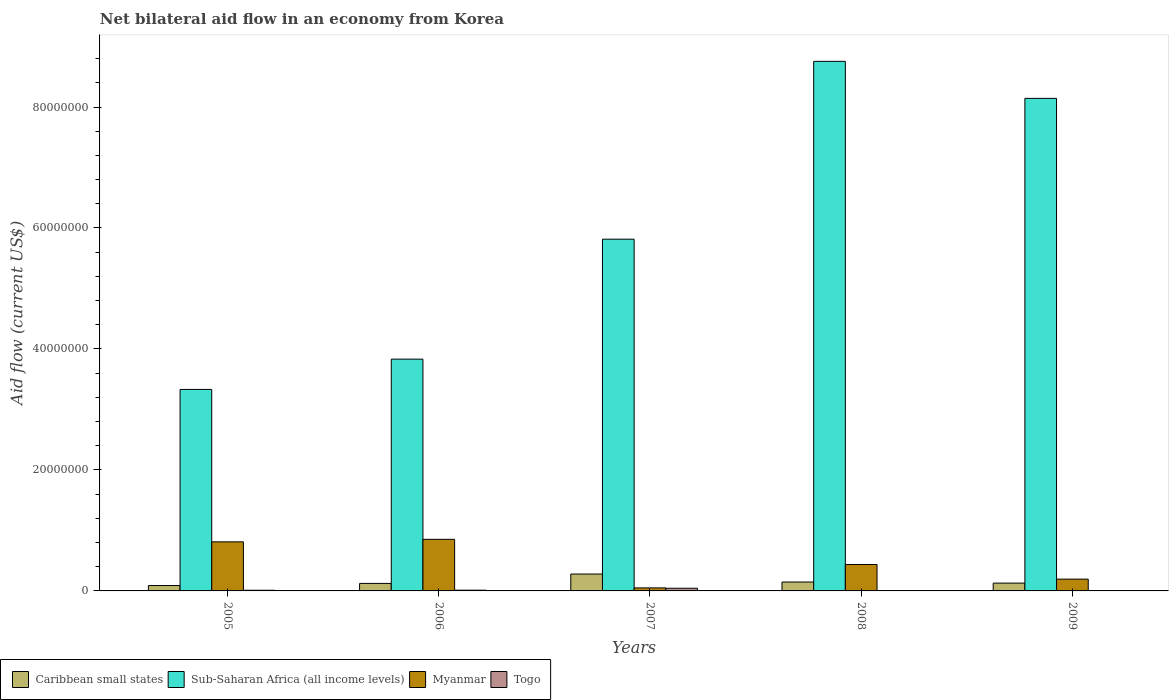How many different coloured bars are there?
Provide a short and direct response. 4. How many groups of bars are there?
Provide a succinct answer. 5. Are the number of bars on each tick of the X-axis equal?
Provide a succinct answer. Yes. How many bars are there on the 4th tick from the left?
Ensure brevity in your answer.  4. In how many cases, is the number of bars for a given year not equal to the number of legend labels?
Keep it short and to the point. 0. Across all years, what is the maximum net bilateral aid flow in Caribbean small states?
Ensure brevity in your answer.  2.79e+06. Across all years, what is the minimum net bilateral aid flow in Sub-Saharan Africa (all income levels)?
Offer a very short reply. 3.33e+07. In which year was the net bilateral aid flow in Myanmar minimum?
Offer a terse response. 2007. What is the total net bilateral aid flow in Caribbean small states in the graph?
Offer a very short reply. 7.68e+06. What is the difference between the net bilateral aid flow in Togo in 2006 and that in 2007?
Make the answer very short. -3.20e+05. What is the difference between the net bilateral aid flow in Togo in 2005 and the net bilateral aid flow in Sub-Saharan Africa (all income levels) in 2006?
Your response must be concise. -3.82e+07. What is the average net bilateral aid flow in Myanmar per year?
Ensure brevity in your answer.  4.69e+06. In the year 2009, what is the difference between the net bilateral aid flow in Caribbean small states and net bilateral aid flow in Togo?
Offer a very short reply. 1.23e+06. What is the ratio of the net bilateral aid flow in Togo in 2005 to that in 2008?
Provide a succinct answer. 1.83. Is the net bilateral aid flow in Myanmar in 2006 less than that in 2009?
Provide a succinct answer. No. What is the difference between the highest and the second highest net bilateral aid flow in Togo?
Provide a succinct answer. 3.20e+05. What is the difference between the highest and the lowest net bilateral aid flow in Sub-Saharan Africa (all income levels)?
Offer a very short reply. 5.42e+07. Is it the case that in every year, the sum of the net bilateral aid flow in Myanmar and net bilateral aid flow in Togo is greater than the sum of net bilateral aid flow in Caribbean small states and net bilateral aid flow in Sub-Saharan Africa (all income levels)?
Make the answer very short. Yes. What does the 1st bar from the left in 2008 represents?
Your answer should be very brief. Caribbean small states. What does the 4th bar from the right in 2009 represents?
Offer a terse response. Caribbean small states. Is it the case that in every year, the sum of the net bilateral aid flow in Myanmar and net bilateral aid flow in Sub-Saharan Africa (all income levels) is greater than the net bilateral aid flow in Togo?
Provide a succinct answer. Yes. How many bars are there?
Provide a short and direct response. 20. How many years are there in the graph?
Keep it short and to the point. 5. Are the values on the major ticks of Y-axis written in scientific E-notation?
Your answer should be very brief. No. Does the graph contain any zero values?
Your answer should be compact. No. Does the graph contain grids?
Provide a short and direct response. No. Where does the legend appear in the graph?
Your answer should be compact. Bottom left. How many legend labels are there?
Keep it short and to the point. 4. How are the legend labels stacked?
Ensure brevity in your answer.  Horizontal. What is the title of the graph?
Provide a succinct answer. Net bilateral aid flow in an economy from Korea. Does "Russian Federation" appear as one of the legend labels in the graph?
Ensure brevity in your answer.  No. What is the label or title of the X-axis?
Make the answer very short. Years. What is the Aid flow (current US$) in Caribbean small states in 2005?
Ensure brevity in your answer.  8.90e+05. What is the Aid flow (current US$) of Sub-Saharan Africa (all income levels) in 2005?
Ensure brevity in your answer.  3.33e+07. What is the Aid flow (current US$) in Myanmar in 2005?
Offer a terse response. 8.11e+06. What is the Aid flow (current US$) of Caribbean small states in 2006?
Give a very brief answer. 1.24e+06. What is the Aid flow (current US$) of Sub-Saharan Africa (all income levels) in 2006?
Your response must be concise. 3.83e+07. What is the Aid flow (current US$) in Myanmar in 2006?
Your response must be concise. 8.53e+06. What is the Aid flow (current US$) of Togo in 2006?
Make the answer very short. 1.20e+05. What is the Aid flow (current US$) in Caribbean small states in 2007?
Your answer should be very brief. 2.79e+06. What is the Aid flow (current US$) of Sub-Saharan Africa (all income levels) in 2007?
Your answer should be very brief. 5.82e+07. What is the Aid flow (current US$) of Myanmar in 2007?
Provide a short and direct response. 5.00e+05. What is the Aid flow (current US$) of Togo in 2007?
Your answer should be very brief. 4.40e+05. What is the Aid flow (current US$) in Caribbean small states in 2008?
Make the answer very short. 1.47e+06. What is the Aid flow (current US$) of Sub-Saharan Africa (all income levels) in 2008?
Ensure brevity in your answer.  8.76e+07. What is the Aid flow (current US$) in Myanmar in 2008?
Give a very brief answer. 4.37e+06. What is the Aid flow (current US$) of Togo in 2008?
Your answer should be very brief. 6.00e+04. What is the Aid flow (current US$) in Caribbean small states in 2009?
Provide a short and direct response. 1.29e+06. What is the Aid flow (current US$) in Sub-Saharan Africa (all income levels) in 2009?
Your response must be concise. 8.14e+07. What is the Aid flow (current US$) of Myanmar in 2009?
Make the answer very short. 1.95e+06. Across all years, what is the maximum Aid flow (current US$) of Caribbean small states?
Make the answer very short. 2.79e+06. Across all years, what is the maximum Aid flow (current US$) of Sub-Saharan Africa (all income levels)?
Keep it short and to the point. 8.76e+07. Across all years, what is the maximum Aid flow (current US$) of Myanmar?
Your response must be concise. 8.53e+06. Across all years, what is the minimum Aid flow (current US$) in Caribbean small states?
Offer a very short reply. 8.90e+05. Across all years, what is the minimum Aid flow (current US$) in Sub-Saharan Africa (all income levels)?
Give a very brief answer. 3.33e+07. What is the total Aid flow (current US$) in Caribbean small states in the graph?
Keep it short and to the point. 7.68e+06. What is the total Aid flow (current US$) of Sub-Saharan Africa (all income levels) in the graph?
Offer a terse response. 2.99e+08. What is the total Aid flow (current US$) in Myanmar in the graph?
Offer a terse response. 2.35e+07. What is the total Aid flow (current US$) in Togo in the graph?
Ensure brevity in your answer.  7.90e+05. What is the difference between the Aid flow (current US$) of Caribbean small states in 2005 and that in 2006?
Provide a succinct answer. -3.50e+05. What is the difference between the Aid flow (current US$) in Sub-Saharan Africa (all income levels) in 2005 and that in 2006?
Ensure brevity in your answer.  -5.01e+06. What is the difference between the Aid flow (current US$) of Myanmar in 2005 and that in 2006?
Ensure brevity in your answer.  -4.20e+05. What is the difference between the Aid flow (current US$) in Togo in 2005 and that in 2006?
Keep it short and to the point. -10000. What is the difference between the Aid flow (current US$) of Caribbean small states in 2005 and that in 2007?
Provide a short and direct response. -1.90e+06. What is the difference between the Aid flow (current US$) in Sub-Saharan Africa (all income levels) in 2005 and that in 2007?
Make the answer very short. -2.48e+07. What is the difference between the Aid flow (current US$) of Myanmar in 2005 and that in 2007?
Make the answer very short. 7.61e+06. What is the difference between the Aid flow (current US$) in Togo in 2005 and that in 2007?
Provide a short and direct response. -3.30e+05. What is the difference between the Aid flow (current US$) in Caribbean small states in 2005 and that in 2008?
Offer a very short reply. -5.80e+05. What is the difference between the Aid flow (current US$) of Sub-Saharan Africa (all income levels) in 2005 and that in 2008?
Your answer should be compact. -5.42e+07. What is the difference between the Aid flow (current US$) in Myanmar in 2005 and that in 2008?
Your answer should be compact. 3.74e+06. What is the difference between the Aid flow (current US$) in Caribbean small states in 2005 and that in 2009?
Keep it short and to the point. -4.00e+05. What is the difference between the Aid flow (current US$) in Sub-Saharan Africa (all income levels) in 2005 and that in 2009?
Ensure brevity in your answer.  -4.81e+07. What is the difference between the Aid flow (current US$) in Myanmar in 2005 and that in 2009?
Make the answer very short. 6.16e+06. What is the difference between the Aid flow (current US$) of Caribbean small states in 2006 and that in 2007?
Your response must be concise. -1.55e+06. What is the difference between the Aid flow (current US$) in Sub-Saharan Africa (all income levels) in 2006 and that in 2007?
Give a very brief answer. -1.98e+07. What is the difference between the Aid flow (current US$) in Myanmar in 2006 and that in 2007?
Your answer should be compact. 8.03e+06. What is the difference between the Aid flow (current US$) of Togo in 2006 and that in 2007?
Provide a succinct answer. -3.20e+05. What is the difference between the Aid flow (current US$) of Caribbean small states in 2006 and that in 2008?
Keep it short and to the point. -2.30e+05. What is the difference between the Aid flow (current US$) of Sub-Saharan Africa (all income levels) in 2006 and that in 2008?
Provide a short and direct response. -4.92e+07. What is the difference between the Aid flow (current US$) of Myanmar in 2006 and that in 2008?
Make the answer very short. 4.16e+06. What is the difference between the Aid flow (current US$) in Caribbean small states in 2006 and that in 2009?
Provide a succinct answer. -5.00e+04. What is the difference between the Aid flow (current US$) of Sub-Saharan Africa (all income levels) in 2006 and that in 2009?
Offer a terse response. -4.31e+07. What is the difference between the Aid flow (current US$) of Myanmar in 2006 and that in 2009?
Keep it short and to the point. 6.58e+06. What is the difference between the Aid flow (current US$) in Caribbean small states in 2007 and that in 2008?
Make the answer very short. 1.32e+06. What is the difference between the Aid flow (current US$) in Sub-Saharan Africa (all income levels) in 2007 and that in 2008?
Provide a short and direct response. -2.94e+07. What is the difference between the Aid flow (current US$) of Myanmar in 2007 and that in 2008?
Provide a short and direct response. -3.87e+06. What is the difference between the Aid flow (current US$) of Caribbean small states in 2007 and that in 2009?
Your answer should be compact. 1.50e+06. What is the difference between the Aid flow (current US$) of Sub-Saharan Africa (all income levels) in 2007 and that in 2009?
Your answer should be very brief. -2.33e+07. What is the difference between the Aid flow (current US$) in Myanmar in 2007 and that in 2009?
Your response must be concise. -1.45e+06. What is the difference between the Aid flow (current US$) in Togo in 2007 and that in 2009?
Offer a very short reply. 3.80e+05. What is the difference between the Aid flow (current US$) in Sub-Saharan Africa (all income levels) in 2008 and that in 2009?
Keep it short and to the point. 6.12e+06. What is the difference between the Aid flow (current US$) of Myanmar in 2008 and that in 2009?
Make the answer very short. 2.42e+06. What is the difference between the Aid flow (current US$) of Caribbean small states in 2005 and the Aid flow (current US$) of Sub-Saharan Africa (all income levels) in 2006?
Offer a terse response. -3.74e+07. What is the difference between the Aid flow (current US$) in Caribbean small states in 2005 and the Aid flow (current US$) in Myanmar in 2006?
Provide a short and direct response. -7.64e+06. What is the difference between the Aid flow (current US$) of Caribbean small states in 2005 and the Aid flow (current US$) of Togo in 2006?
Offer a terse response. 7.70e+05. What is the difference between the Aid flow (current US$) in Sub-Saharan Africa (all income levels) in 2005 and the Aid flow (current US$) in Myanmar in 2006?
Provide a short and direct response. 2.48e+07. What is the difference between the Aid flow (current US$) in Sub-Saharan Africa (all income levels) in 2005 and the Aid flow (current US$) in Togo in 2006?
Ensure brevity in your answer.  3.32e+07. What is the difference between the Aid flow (current US$) of Myanmar in 2005 and the Aid flow (current US$) of Togo in 2006?
Make the answer very short. 7.99e+06. What is the difference between the Aid flow (current US$) of Caribbean small states in 2005 and the Aid flow (current US$) of Sub-Saharan Africa (all income levels) in 2007?
Offer a very short reply. -5.73e+07. What is the difference between the Aid flow (current US$) of Caribbean small states in 2005 and the Aid flow (current US$) of Myanmar in 2007?
Give a very brief answer. 3.90e+05. What is the difference between the Aid flow (current US$) of Sub-Saharan Africa (all income levels) in 2005 and the Aid flow (current US$) of Myanmar in 2007?
Your response must be concise. 3.28e+07. What is the difference between the Aid flow (current US$) in Sub-Saharan Africa (all income levels) in 2005 and the Aid flow (current US$) in Togo in 2007?
Provide a succinct answer. 3.29e+07. What is the difference between the Aid flow (current US$) of Myanmar in 2005 and the Aid flow (current US$) of Togo in 2007?
Ensure brevity in your answer.  7.67e+06. What is the difference between the Aid flow (current US$) of Caribbean small states in 2005 and the Aid flow (current US$) of Sub-Saharan Africa (all income levels) in 2008?
Offer a very short reply. -8.67e+07. What is the difference between the Aid flow (current US$) of Caribbean small states in 2005 and the Aid flow (current US$) of Myanmar in 2008?
Give a very brief answer. -3.48e+06. What is the difference between the Aid flow (current US$) of Caribbean small states in 2005 and the Aid flow (current US$) of Togo in 2008?
Keep it short and to the point. 8.30e+05. What is the difference between the Aid flow (current US$) in Sub-Saharan Africa (all income levels) in 2005 and the Aid flow (current US$) in Myanmar in 2008?
Your answer should be very brief. 2.89e+07. What is the difference between the Aid flow (current US$) of Sub-Saharan Africa (all income levels) in 2005 and the Aid flow (current US$) of Togo in 2008?
Give a very brief answer. 3.32e+07. What is the difference between the Aid flow (current US$) in Myanmar in 2005 and the Aid flow (current US$) in Togo in 2008?
Provide a succinct answer. 8.05e+06. What is the difference between the Aid flow (current US$) in Caribbean small states in 2005 and the Aid flow (current US$) in Sub-Saharan Africa (all income levels) in 2009?
Give a very brief answer. -8.05e+07. What is the difference between the Aid flow (current US$) in Caribbean small states in 2005 and the Aid flow (current US$) in Myanmar in 2009?
Provide a short and direct response. -1.06e+06. What is the difference between the Aid flow (current US$) in Caribbean small states in 2005 and the Aid flow (current US$) in Togo in 2009?
Offer a very short reply. 8.30e+05. What is the difference between the Aid flow (current US$) of Sub-Saharan Africa (all income levels) in 2005 and the Aid flow (current US$) of Myanmar in 2009?
Your response must be concise. 3.14e+07. What is the difference between the Aid flow (current US$) in Sub-Saharan Africa (all income levels) in 2005 and the Aid flow (current US$) in Togo in 2009?
Your answer should be compact. 3.32e+07. What is the difference between the Aid flow (current US$) in Myanmar in 2005 and the Aid flow (current US$) in Togo in 2009?
Provide a short and direct response. 8.05e+06. What is the difference between the Aid flow (current US$) of Caribbean small states in 2006 and the Aid flow (current US$) of Sub-Saharan Africa (all income levels) in 2007?
Offer a terse response. -5.69e+07. What is the difference between the Aid flow (current US$) in Caribbean small states in 2006 and the Aid flow (current US$) in Myanmar in 2007?
Your answer should be compact. 7.40e+05. What is the difference between the Aid flow (current US$) in Caribbean small states in 2006 and the Aid flow (current US$) in Togo in 2007?
Make the answer very short. 8.00e+05. What is the difference between the Aid flow (current US$) in Sub-Saharan Africa (all income levels) in 2006 and the Aid flow (current US$) in Myanmar in 2007?
Give a very brief answer. 3.78e+07. What is the difference between the Aid flow (current US$) of Sub-Saharan Africa (all income levels) in 2006 and the Aid flow (current US$) of Togo in 2007?
Ensure brevity in your answer.  3.79e+07. What is the difference between the Aid flow (current US$) of Myanmar in 2006 and the Aid flow (current US$) of Togo in 2007?
Offer a very short reply. 8.09e+06. What is the difference between the Aid flow (current US$) in Caribbean small states in 2006 and the Aid flow (current US$) in Sub-Saharan Africa (all income levels) in 2008?
Offer a terse response. -8.63e+07. What is the difference between the Aid flow (current US$) of Caribbean small states in 2006 and the Aid flow (current US$) of Myanmar in 2008?
Give a very brief answer. -3.13e+06. What is the difference between the Aid flow (current US$) of Caribbean small states in 2006 and the Aid flow (current US$) of Togo in 2008?
Provide a succinct answer. 1.18e+06. What is the difference between the Aid flow (current US$) in Sub-Saharan Africa (all income levels) in 2006 and the Aid flow (current US$) in Myanmar in 2008?
Your response must be concise. 3.40e+07. What is the difference between the Aid flow (current US$) in Sub-Saharan Africa (all income levels) in 2006 and the Aid flow (current US$) in Togo in 2008?
Provide a succinct answer. 3.83e+07. What is the difference between the Aid flow (current US$) in Myanmar in 2006 and the Aid flow (current US$) in Togo in 2008?
Provide a short and direct response. 8.47e+06. What is the difference between the Aid flow (current US$) of Caribbean small states in 2006 and the Aid flow (current US$) of Sub-Saharan Africa (all income levels) in 2009?
Ensure brevity in your answer.  -8.02e+07. What is the difference between the Aid flow (current US$) of Caribbean small states in 2006 and the Aid flow (current US$) of Myanmar in 2009?
Provide a succinct answer. -7.10e+05. What is the difference between the Aid flow (current US$) of Caribbean small states in 2006 and the Aid flow (current US$) of Togo in 2009?
Your response must be concise. 1.18e+06. What is the difference between the Aid flow (current US$) of Sub-Saharan Africa (all income levels) in 2006 and the Aid flow (current US$) of Myanmar in 2009?
Give a very brief answer. 3.64e+07. What is the difference between the Aid flow (current US$) of Sub-Saharan Africa (all income levels) in 2006 and the Aid flow (current US$) of Togo in 2009?
Offer a terse response. 3.83e+07. What is the difference between the Aid flow (current US$) of Myanmar in 2006 and the Aid flow (current US$) of Togo in 2009?
Give a very brief answer. 8.47e+06. What is the difference between the Aid flow (current US$) of Caribbean small states in 2007 and the Aid flow (current US$) of Sub-Saharan Africa (all income levels) in 2008?
Your answer should be compact. -8.48e+07. What is the difference between the Aid flow (current US$) of Caribbean small states in 2007 and the Aid flow (current US$) of Myanmar in 2008?
Make the answer very short. -1.58e+06. What is the difference between the Aid flow (current US$) in Caribbean small states in 2007 and the Aid flow (current US$) in Togo in 2008?
Offer a terse response. 2.73e+06. What is the difference between the Aid flow (current US$) in Sub-Saharan Africa (all income levels) in 2007 and the Aid flow (current US$) in Myanmar in 2008?
Make the answer very short. 5.38e+07. What is the difference between the Aid flow (current US$) of Sub-Saharan Africa (all income levels) in 2007 and the Aid flow (current US$) of Togo in 2008?
Your answer should be very brief. 5.81e+07. What is the difference between the Aid flow (current US$) in Caribbean small states in 2007 and the Aid flow (current US$) in Sub-Saharan Africa (all income levels) in 2009?
Provide a short and direct response. -7.86e+07. What is the difference between the Aid flow (current US$) of Caribbean small states in 2007 and the Aid flow (current US$) of Myanmar in 2009?
Ensure brevity in your answer.  8.40e+05. What is the difference between the Aid flow (current US$) of Caribbean small states in 2007 and the Aid flow (current US$) of Togo in 2009?
Your answer should be compact. 2.73e+06. What is the difference between the Aid flow (current US$) in Sub-Saharan Africa (all income levels) in 2007 and the Aid flow (current US$) in Myanmar in 2009?
Your response must be concise. 5.62e+07. What is the difference between the Aid flow (current US$) of Sub-Saharan Africa (all income levels) in 2007 and the Aid flow (current US$) of Togo in 2009?
Provide a succinct answer. 5.81e+07. What is the difference between the Aid flow (current US$) in Caribbean small states in 2008 and the Aid flow (current US$) in Sub-Saharan Africa (all income levels) in 2009?
Provide a succinct answer. -8.00e+07. What is the difference between the Aid flow (current US$) of Caribbean small states in 2008 and the Aid flow (current US$) of Myanmar in 2009?
Provide a succinct answer. -4.80e+05. What is the difference between the Aid flow (current US$) in Caribbean small states in 2008 and the Aid flow (current US$) in Togo in 2009?
Keep it short and to the point. 1.41e+06. What is the difference between the Aid flow (current US$) in Sub-Saharan Africa (all income levels) in 2008 and the Aid flow (current US$) in Myanmar in 2009?
Make the answer very short. 8.56e+07. What is the difference between the Aid flow (current US$) of Sub-Saharan Africa (all income levels) in 2008 and the Aid flow (current US$) of Togo in 2009?
Offer a very short reply. 8.75e+07. What is the difference between the Aid flow (current US$) in Myanmar in 2008 and the Aid flow (current US$) in Togo in 2009?
Offer a terse response. 4.31e+06. What is the average Aid flow (current US$) of Caribbean small states per year?
Your answer should be very brief. 1.54e+06. What is the average Aid flow (current US$) of Sub-Saharan Africa (all income levels) per year?
Make the answer very short. 5.98e+07. What is the average Aid flow (current US$) of Myanmar per year?
Offer a terse response. 4.69e+06. What is the average Aid flow (current US$) of Togo per year?
Your answer should be compact. 1.58e+05. In the year 2005, what is the difference between the Aid flow (current US$) of Caribbean small states and Aid flow (current US$) of Sub-Saharan Africa (all income levels)?
Your answer should be compact. -3.24e+07. In the year 2005, what is the difference between the Aid flow (current US$) in Caribbean small states and Aid flow (current US$) in Myanmar?
Your response must be concise. -7.22e+06. In the year 2005, what is the difference between the Aid flow (current US$) of Caribbean small states and Aid flow (current US$) of Togo?
Offer a terse response. 7.80e+05. In the year 2005, what is the difference between the Aid flow (current US$) in Sub-Saharan Africa (all income levels) and Aid flow (current US$) in Myanmar?
Your answer should be very brief. 2.52e+07. In the year 2005, what is the difference between the Aid flow (current US$) of Sub-Saharan Africa (all income levels) and Aid flow (current US$) of Togo?
Ensure brevity in your answer.  3.32e+07. In the year 2005, what is the difference between the Aid flow (current US$) in Myanmar and Aid flow (current US$) in Togo?
Your answer should be very brief. 8.00e+06. In the year 2006, what is the difference between the Aid flow (current US$) in Caribbean small states and Aid flow (current US$) in Sub-Saharan Africa (all income levels)?
Offer a terse response. -3.71e+07. In the year 2006, what is the difference between the Aid flow (current US$) of Caribbean small states and Aid flow (current US$) of Myanmar?
Ensure brevity in your answer.  -7.29e+06. In the year 2006, what is the difference between the Aid flow (current US$) of Caribbean small states and Aid flow (current US$) of Togo?
Ensure brevity in your answer.  1.12e+06. In the year 2006, what is the difference between the Aid flow (current US$) in Sub-Saharan Africa (all income levels) and Aid flow (current US$) in Myanmar?
Provide a succinct answer. 2.98e+07. In the year 2006, what is the difference between the Aid flow (current US$) of Sub-Saharan Africa (all income levels) and Aid flow (current US$) of Togo?
Your answer should be compact. 3.82e+07. In the year 2006, what is the difference between the Aid flow (current US$) of Myanmar and Aid flow (current US$) of Togo?
Give a very brief answer. 8.41e+06. In the year 2007, what is the difference between the Aid flow (current US$) in Caribbean small states and Aid flow (current US$) in Sub-Saharan Africa (all income levels)?
Make the answer very short. -5.54e+07. In the year 2007, what is the difference between the Aid flow (current US$) of Caribbean small states and Aid flow (current US$) of Myanmar?
Give a very brief answer. 2.29e+06. In the year 2007, what is the difference between the Aid flow (current US$) in Caribbean small states and Aid flow (current US$) in Togo?
Keep it short and to the point. 2.35e+06. In the year 2007, what is the difference between the Aid flow (current US$) in Sub-Saharan Africa (all income levels) and Aid flow (current US$) in Myanmar?
Give a very brief answer. 5.76e+07. In the year 2007, what is the difference between the Aid flow (current US$) in Sub-Saharan Africa (all income levels) and Aid flow (current US$) in Togo?
Ensure brevity in your answer.  5.77e+07. In the year 2007, what is the difference between the Aid flow (current US$) of Myanmar and Aid flow (current US$) of Togo?
Provide a succinct answer. 6.00e+04. In the year 2008, what is the difference between the Aid flow (current US$) in Caribbean small states and Aid flow (current US$) in Sub-Saharan Africa (all income levels)?
Ensure brevity in your answer.  -8.61e+07. In the year 2008, what is the difference between the Aid flow (current US$) in Caribbean small states and Aid flow (current US$) in Myanmar?
Provide a succinct answer. -2.90e+06. In the year 2008, what is the difference between the Aid flow (current US$) in Caribbean small states and Aid flow (current US$) in Togo?
Your response must be concise. 1.41e+06. In the year 2008, what is the difference between the Aid flow (current US$) of Sub-Saharan Africa (all income levels) and Aid flow (current US$) of Myanmar?
Your answer should be very brief. 8.32e+07. In the year 2008, what is the difference between the Aid flow (current US$) of Sub-Saharan Africa (all income levels) and Aid flow (current US$) of Togo?
Make the answer very short. 8.75e+07. In the year 2008, what is the difference between the Aid flow (current US$) in Myanmar and Aid flow (current US$) in Togo?
Your answer should be very brief. 4.31e+06. In the year 2009, what is the difference between the Aid flow (current US$) in Caribbean small states and Aid flow (current US$) in Sub-Saharan Africa (all income levels)?
Provide a succinct answer. -8.01e+07. In the year 2009, what is the difference between the Aid flow (current US$) in Caribbean small states and Aid flow (current US$) in Myanmar?
Your answer should be very brief. -6.60e+05. In the year 2009, what is the difference between the Aid flow (current US$) in Caribbean small states and Aid flow (current US$) in Togo?
Provide a succinct answer. 1.23e+06. In the year 2009, what is the difference between the Aid flow (current US$) in Sub-Saharan Africa (all income levels) and Aid flow (current US$) in Myanmar?
Provide a succinct answer. 7.95e+07. In the year 2009, what is the difference between the Aid flow (current US$) of Sub-Saharan Africa (all income levels) and Aid flow (current US$) of Togo?
Your answer should be compact. 8.14e+07. In the year 2009, what is the difference between the Aid flow (current US$) of Myanmar and Aid flow (current US$) of Togo?
Give a very brief answer. 1.89e+06. What is the ratio of the Aid flow (current US$) in Caribbean small states in 2005 to that in 2006?
Provide a short and direct response. 0.72. What is the ratio of the Aid flow (current US$) of Sub-Saharan Africa (all income levels) in 2005 to that in 2006?
Provide a succinct answer. 0.87. What is the ratio of the Aid flow (current US$) of Myanmar in 2005 to that in 2006?
Offer a very short reply. 0.95. What is the ratio of the Aid flow (current US$) in Caribbean small states in 2005 to that in 2007?
Make the answer very short. 0.32. What is the ratio of the Aid flow (current US$) in Sub-Saharan Africa (all income levels) in 2005 to that in 2007?
Provide a succinct answer. 0.57. What is the ratio of the Aid flow (current US$) of Myanmar in 2005 to that in 2007?
Make the answer very short. 16.22. What is the ratio of the Aid flow (current US$) of Caribbean small states in 2005 to that in 2008?
Your answer should be very brief. 0.61. What is the ratio of the Aid flow (current US$) of Sub-Saharan Africa (all income levels) in 2005 to that in 2008?
Your response must be concise. 0.38. What is the ratio of the Aid flow (current US$) in Myanmar in 2005 to that in 2008?
Your answer should be compact. 1.86. What is the ratio of the Aid flow (current US$) of Togo in 2005 to that in 2008?
Your answer should be very brief. 1.83. What is the ratio of the Aid flow (current US$) of Caribbean small states in 2005 to that in 2009?
Keep it short and to the point. 0.69. What is the ratio of the Aid flow (current US$) in Sub-Saharan Africa (all income levels) in 2005 to that in 2009?
Offer a terse response. 0.41. What is the ratio of the Aid flow (current US$) in Myanmar in 2005 to that in 2009?
Provide a short and direct response. 4.16. What is the ratio of the Aid flow (current US$) in Togo in 2005 to that in 2009?
Your response must be concise. 1.83. What is the ratio of the Aid flow (current US$) of Caribbean small states in 2006 to that in 2007?
Make the answer very short. 0.44. What is the ratio of the Aid flow (current US$) in Sub-Saharan Africa (all income levels) in 2006 to that in 2007?
Your answer should be very brief. 0.66. What is the ratio of the Aid flow (current US$) in Myanmar in 2006 to that in 2007?
Give a very brief answer. 17.06. What is the ratio of the Aid flow (current US$) of Togo in 2006 to that in 2007?
Provide a succinct answer. 0.27. What is the ratio of the Aid flow (current US$) of Caribbean small states in 2006 to that in 2008?
Keep it short and to the point. 0.84. What is the ratio of the Aid flow (current US$) of Sub-Saharan Africa (all income levels) in 2006 to that in 2008?
Provide a short and direct response. 0.44. What is the ratio of the Aid flow (current US$) in Myanmar in 2006 to that in 2008?
Offer a very short reply. 1.95. What is the ratio of the Aid flow (current US$) in Caribbean small states in 2006 to that in 2009?
Your answer should be compact. 0.96. What is the ratio of the Aid flow (current US$) of Sub-Saharan Africa (all income levels) in 2006 to that in 2009?
Provide a short and direct response. 0.47. What is the ratio of the Aid flow (current US$) in Myanmar in 2006 to that in 2009?
Your response must be concise. 4.37. What is the ratio of the Aid flow (current US$) in Caribbean small states in 2007 to that in 2008?
Provide a succinct answer. 1.9. What is the ratio of the Aid flow (current US$) of Sub-Saharan Africa (all income levels) in 2007 to that in 2008?
Offer a terse response. 0.66. What is the ratio of the Aid flow (current US$) of Myanmar in 2007 to that in 2008?
Provide a short and direct response. 0.11. What is the ratio of the Aid flow (current US$) of Togo in 2007 to that in 2008?
Ensure brevity in your answer.  7.33. What is the ratio of the Aid flow (current US$) in Caribbean small states in 2007 to that in 2009?
Offer a terse response. 2.16. What is the ratio of the Aid flow (current US$) in Sub-Saharan Africa (all income levels) in 2007 to that in 2009?
Keep it short and to the point. 0.71. What is the ratio of the Aid flow (current US$) of Myanmar in 2007 to that in 2009?
Ensure brevity in your answer.  0.26. What is the ratio of the Aid flow (current US$) of Togo in 2007 to that in 2009?
Your response must be concise. 7.33. What is the ratio of the Aid flow (current US$) in Caribbean small states in 2008 to that in 2009?
Your answer should be very brief. 1.14. What is the ratio of the Aid flow (current US$) of Sub-Saharan Africa (all income levels) in 2008 to that in 2009?
Provide a succinct answer. 1.08. What is the ratio of the Aid flow (current US$) in Myanmar in 2008 to that in 2009?
Keep it short and to the point. 2.24. What is the ratio of the Aid flow (current US$) in Togo in 2008 to that in 2009?
Offer a very short reply. 1. What is the difference between the highest and the second highest Aid flow (current US$) of Caribbean small states?
Give a very brief answer. 1.32e+06. What is the difference between the highest and the second highest Aid flow (current US$) in Sub-Saharan Africa (all income levels)?
Offer a very short reply. 6.12e+06. What is the difference between the highest and the second highest Aid flow (current US$) in Togo?
Offer a very short reply. 3.20e+05. What is the difference between the highest and the lowest Aid flow (current US$) of Caribbean small states?
Your answer should be very brief. 1.90e+06. What is the difference between the highest and the lowest Aid flow (current US$) of Sub-Saharan Africa (all income levels)?
Make the answer very short. 5.42e+07. What is the difference between the highest and the lowest Aid flow (current US$) of Myanmar?
Your answer should be compact. 8.03e+06. 